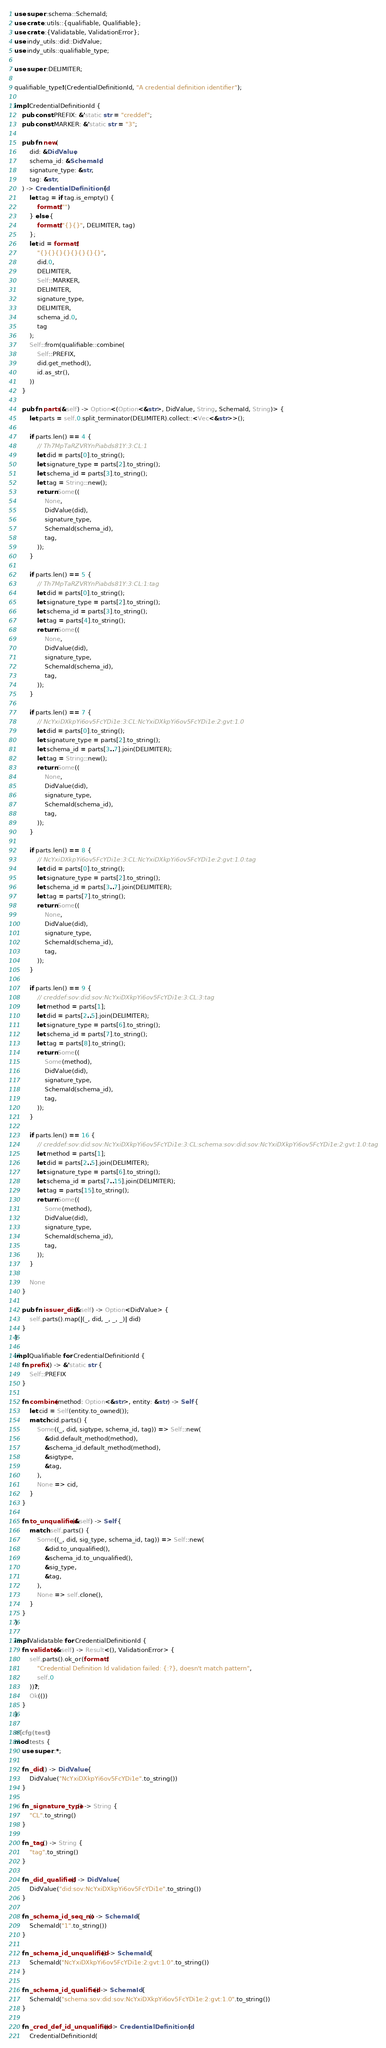Convert code to text. <code><loc_0><loc_0><loc_500><loc_500><_Rust_>use super::schema::SchemaId;
use crate::utils::{qualifiable, Qualifiable};
use crate::{Validatable, ValidationError};
use indy_utils::did::DidValue;
use indy_utils::qualifiable_type;

use super::DELIMITER;

qualifiable_type!(CredentialDefinitionId, "A credential definition identifier");

impl CredentialDefinitionId {
    pub const PREFIX: &'static str = "creddef";
    pub const MARKER: &'static str = "3";

    pub fn new(
        did: &DidValue,
        schema_id: &SchemaId,
        signature_type: &str,
        tag: &str,
    ) -> CredentialDefinitionId {
        let tag = if tag.is_empty() {
            format!("")
        } else {
            format!("{}{}", DELIMITER, tag)
        };
        let id = format!(
            "{}{}{}{}{}{}{}{}",
            did.0,
            DELIMITER,
            Self::MARKER,
            DELIMITER,
            signature_type,
            DELIMITER,
            schema_id.0,
            tag
        );
        Self::from(qualifiable::combine(
            Self::PREFIX,
            did.get_method(),
            id.as_str(),
        ))
    }

    pub fn parts(&self) -> Option<(Option<&str>, DidValue, String, SchemaId, String)> {
        let parts = self.0.split_terminator(DELIMITER).collect::<Vec<&str>>();

        if parts.len() == 4 {
            // Th7MpTaRZVRYnPiabds81Y:3:CL:1
            let did = parts[0].to_string();
            let signature_type = parts[2].to_string();
            let schema_id = parts[3].to_string();
            let tag = String::new();
            return Some((
                None,
                DidValue(did),
                signature_type,
                SchemaId(schema_id),
                tag,
            ));
        }

        if parts.len() == 5 {
            // Th7MpTaRZVRYnPiabds81Y:3:CL:1:tag
            let did = parts[0].to_string();
            let signature_type = parts[2].to_string();
            let schema_id = parts[3].to_string();
            let tag = parts[4].to_string();
            return Some((
                None,
                DidValue(did),
                signature_type,
                SchemaId(schema_id),
                tag,
            ));
        }

        if parts.len() == 7 {
            // NcYxiDXkpYi6ov5FcYDi1e:3:CL:NcYxiDXkpYi6ov5FcYDi1e:2:gvt:1.0
            let did = parts[0].to_string();
            let signature_type = parts[2].to_string();
            let schema_id = parts[3..7].join(DELIMITER);
            let tag = String::new();
            return Some((
                None,
                DidValue(did),
                signature_type,
                SchemaId(schema_id),
                tag,
            ));
        }

        if parts.len() == 8 {
            // NcYxiDXkpYi6ov5FcYDi1e:3:CL:NcYxiDXkpYi6ov5FcYDi1e:2:gvt:1.0:tag
            let did = parts[0].to_string();
            let signature_type = parts[2].to_string();
            let schema_id = parts[3..7].join(DELIMITER);
            let tag = parts[7].to_string();
            return Some((
                None,
                DidValue(did),
                signature_type,
                SchemaId(schema_id),
                tag,
            ));
        }

        if parts.len() == 9 {
            // creddef:sov:did:sov:NcYxiDXkpYi6ov5FcYDi1e:3:CL:3:tag
            let method = parts[1];
            let did = parts[2..5].join(DELIMITER);
            let signature_type = parts[6].to_string();
            let schema_id = parts[7].to_string();
            let tag = parts[8].to_string();
            return Some((
                Some(method),
                DidValue(did),
                signature_type,
                SchemaId(schema_id),
                tag,
            ));
        }

        if parts.len() == 16 {
            // creddef:sov:did:sov:NcYxiDXkpYi6ov5FcYDi1e:3:CL:schema:sov:did:sov:NcYxiDXkpYi6ov5FcYDi1e:2:gvt:1.0:tag
            let method = parts[1];
            let did = parts[2..5].join(DELIMITER);
            let signature_type = parts[6].to_string();
            let schema_id = parts[7..15].join(DELIMITER);
            let tag = parts[15].to_string();
            return Some((
                Some(method),
                DidValue(did),
                signature_type,
                SchemaId(schema_id),
                tag,
            ));
        }

        None
    }

    pub fn issuer_did(&self) -> Option<DidValue> {
        self.parts().map(|(_, did, _, _, _)| did)
    }
}

impl Qualifiable for CredentialDefinitionId {
    fn prefix() -> &'static str {
        Self::PREFIX
    }

    fn combine(method: Option<&str>, entity: &str) -> Self {
        let cid = Self(entity.to_owned());
        match cid.parts() {
            Some((_, did, sigtype, schema_id, tag)) => Self::new(
                &did.default_method(method),
                &schema_id.default_method(method),
                &sigtype,
                &tag,
            ),
            None => cid,
        }
    }

    fn to_unqualified(&self) -> Self {
        match self.parts() {
            Some((_, did, sig_type, schema_id, tag)) => Self::new(
                &did.to_unqualified(),
                &schema_id.to_unqualified(),
                &sig_type,
                &tag,
            ),
            None => self.clone(),
        }
    }
}

impl Validatable for CredentialDefinitionId {
    fn validate(&self) -> Result<(), ValidationError> {
        self.parts().ok_or(format!(
            "Credential Definition Id validation failed: {:?}, doesn't match pattern",
            self.0
        ))?;
        Ok(())
    }
}

#[cfg(test)]
mod tests {
    use super::*;

    fn _did() -> DidValue {
        DidValue("NcYxiDXkpYi6ov5FcYDi1e".to_string())
    }

    fn _signature_type() -> String {
        "CL".to_string()
    }

    fn _tag() -> String {
        "tag".to_string()
    }

    fn _did_qualified() -> DidValue {
        DidValue("did:sov:NcYxiDXkpYi6ov5FcYDi1e".to_string())
    }

    fn _schema_id_seq_no() -> SchemaId {
        SchemaId("1".to_string())
    }

    fn _schema_id_unqualified() -> SchemaId {
        SchemaId("NcYxiDXkpYi6ov5FcYDi1e:2:gvt:1.0".to_string())
    }

    fn _schema_id_qualified() -> SchemaId {
        SchemaId("schema:sov:did:sov:NcYxiDXkpYi6ov5FcYDi1e:2:gvt:1.0".to_string())
    }

    fn _cred_def_id_unqualified() -> CredentialDefinitionId {
        CredentialDefinitionId(</code> 